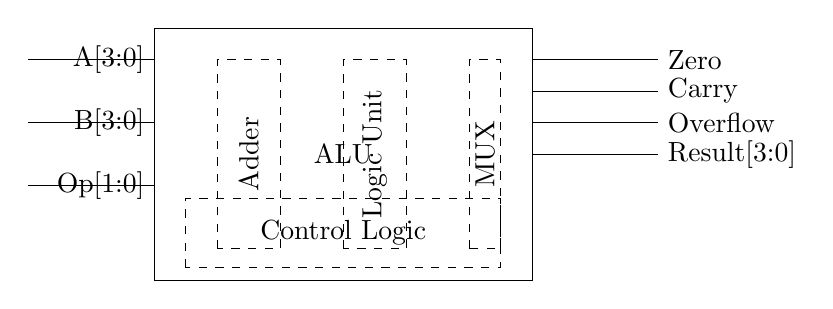What is the function of the ALU in this circuit? The ALU, or Arithmetic Logic Unit, is designed to perform arithmetic and logic operations on the input binary numbers A and B based on the operation selected.
Answer: Arithmetic Logic Unit What are the two input binary numbers represented in the circuit? The circuit shows input lines labeled A[3:0] and B[3:0], indicating they are both 4-bit binary numbers.
Answer: A[3:0] and B[3:0] What is the purpose of the Operation Select signals? The Operation Select signals, labeled Op[1:0], determine which specific arithmetic or logic operation the ALU will perform on the inputs A and B.
Answer: Determine operation How many output flags are indicated in the diagram? The circuit diagram shows three output flags: Zero, Carry, and Overflow.
Answer: Three What components are included in the internal design of the ALU? The internal components include an Adder for arithmetic operations, a Logic Unit for logic operations, and a Multiplexer (MUX) for selecting the output.
Answer: Adder, Logic Unit, MUX What does the Control Logic component do in this ALU? The Control Logic component manages the operation of the ALU by interpreting the Operation Select signals and directing the internal components accordingly.
Answer: Manages ALU operations What are the dimensions of the ALU block in the diagram? The ALU block is drawn as a rectangle with dimensions from coordinate (0,0) to (6,4), indicating a width of 6 units and a height of 4 units.
Answer: Six by four 